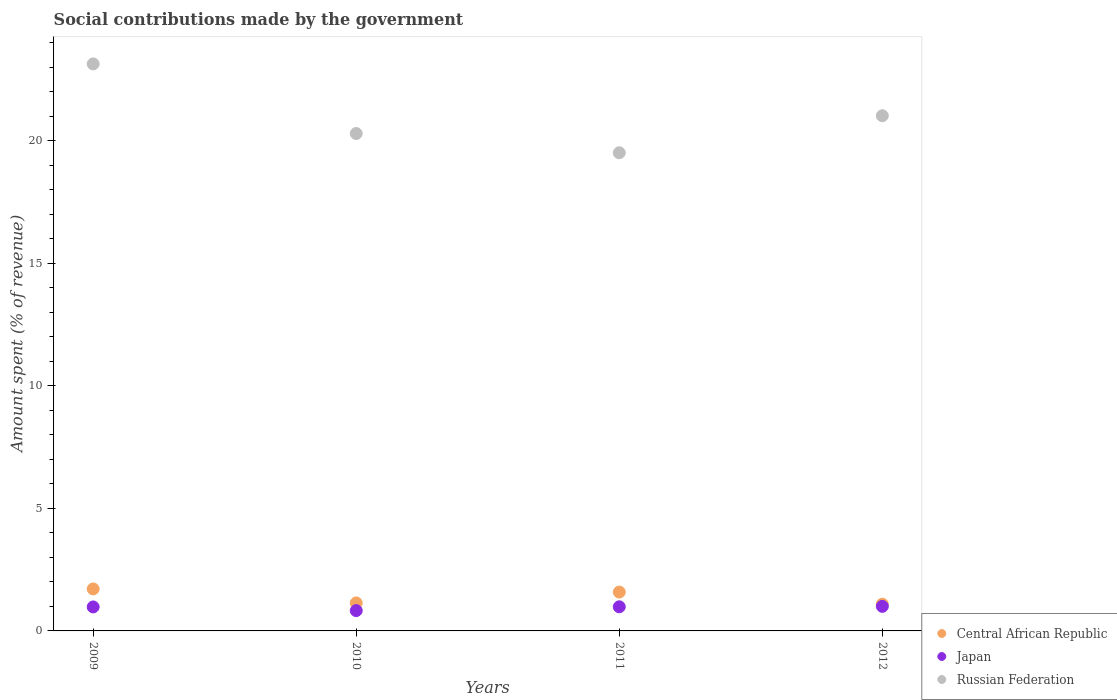What is the amount spent (in %) on social contributions in Russian Federation in 2011?
Make the answer very short. 19.5. Across all years, what is the maximum amount spent (in %) on social contributions in Central African Republic?
Make the answer very short. 1.71. Across all years, what is the minimum amount spent (in %) on social contributions in Russian Federation?
Offer a terse response. 19.5. What is the total amount spent (in %) on social contributions in Central African Republic in the graph?
Your response must be concise. 5.53. What is the difference between the amount spent (in %) on social contributions in Russian Federation in 2010 and that in 2011?
Provide a succinct answer. 0.78. What is the difference between the amount spent (in %) on social contributions in Central African Republic in 2011 and the amount spent (in %) on social contributions in Japan in 2010?
Your answer should be very brief. 0.76. What is the average amount spent (in %) on social contributions in Russian Federation per year?
Your response must be concise. 20.98. In the year 2010, what is the difference between the amount spent (in %) on social contributions in Russian Federation and amount spent (in %) on social contributions in Japan?
Offer a very short reply. 19.46. In how many years, is the amount spent (in %) on social contributions in Japan greater than 11 %?
Keep it short and to the point. 0. What is the ratio of the amount spent (in %) on social contributions in Japan in 2009 to that in 2010?
Give a very brief answer. 1.18. Is the difference between the amount spent (in %) on social contributions in Russian Federation in 2010 and 2012 greater than the difference between the amount spent (in %) on social contributions in Japan in 2010 and 2012?
Provide a succinct answer. No. What is the difference between the highest and the second highest amount spent (in %) on social contributions in Japan?
Your answer should be very brief. 0.02. What is the difference between the highest and the lowest amount spent (in %) on social contributions in Russian Federation?
Your response must be concise. 3.62. Is the sum of the amount spent (in %) on social contributions in Central African Republic in 2009 and 2010 greater than the maximum amount spent (in %) on social contributions in Japan across all years?
Make the answer very short. Yes. How many dotlines are there?
Make the answer very short. 3. Are the values on the major ticks of Y-axis written in scientific E-notation?
Offer a terse response. No. Does the graph contain grids?
Offer a terse response. No. What is the title of the graph?
Make the answer very short. Social contributions made by the government. Does "Kosovo" appear as one of the legend labels in the graph?
Provide a short and direct response. No. What is the label or title of the Y-axis?
Give a very brief answer. Amount spent (% of revenue). What is the Amount spent (% of revenue) in Central African Republic in 2009?
Keep it short and to the point. 1.71. What is the Amount spent (% of revenue) in Japan in 2009?
Ensure brevity in your answer.  0.98. What is the Amount spent (% of revenue) of Russian Federation in 2009?
Offer a very short reply. 23.13. What is the Amount spent (% of revenue) in Central African Republic in 2010?
Ensure brevity in your answer.  1.14. What is the Amount spent (% of revenue) in Japan in 2010?
Offer a very short reply. 0.83. What is the Amount spent (% of revenue) in Russian Federation in 2010?
Provide a short and direct response. 20.29. What is the Amount spent (% of revenue) of Central African Republic in 2011?
Give a very brief answer. 1.58. What is the Amount spent (% of revenue) of Japan in 2011?
Provide a short and direct response. 0.98. What is the Amount spent (% of revenue) of Russian Federation in 2011?
Your answer should be very brief. 19.5. What is the Amount spent (% of revenue) of Central African Republic in 2012?
Offer a very short reply. 1.09. What is the Amount spent (% of revenue) in Japan in 2012?
Your answer should be very brief. 1. What is the Amount spent (% of revenue) in Russian Federation in 2012?
Ensure brevity in your answer.  21.01. Across all years, what is the maximum Amount spent (% of revenue) in Central African Republic?
Make the answer very short. 1.71. Across all years, what is the maximum Amount spent (% of revenue) of Japan?
Provide a succinct answer. 1. Across all years, what is the maximum Amount spent (% of revenue) of Russian Federation?
Keep it short and to the point. 23.13. Across all years, what is the minimum Amount spent (% of revenue) in Central African Republic?
Offer a very short reply. 1.09. Across all years, what is the minimum Amount spent (% of revenue) of Japan?
Your answer should be compact. 0.83. Across all years, what is the minimum Amount spent (% of revenue) in Russian Federation?
Make the answer very short. 19.5. What is the total Amount spent (% of revenue) in Central African Republic in the graph?
Your answer should be very brief. 5.53. What is the total Amount spent (% of revenue) of Japan in the graph?
Make the answer very short. 3.79. What is the total Amount spent (% of revenue) in Russian Federation in the graph?
Provide a short and direct response. 83.94. What is the difference between the Amount spent (% of revenue) in Central African Republic in 2009 and that in 2010?
Provide a succinct answer. 0.57. What is the difference between the Amount spent (% of revenue) of Japan in 2009 and that in 2010?
Provide a short and direct response. 0.15. What is the difference between the Amount spent (% of revenue) in Russian Federation in 2009 and that in 2010?
Provide a short and direct response. 2.84. What is the difference between the Amount spent (% of revenue) of Central African Republic in 2009 and that in 2011?
Provide a succinct answer. 0.13. What is the difference between the Amount spent (% of revenue) in Japan in 2009 and that in 2011?
Provide a succinct answer. -0.01. What is the difference between the Amount spent (% of revenue) of Russian Federation in 2009 and that in 2011?
Offer a terse response. 3.62. What is the difference between the Amount spent (% of revenue) in Central African Republic in 2009 and that in 2012?
Offer a terse response. 0.62. What is the difference between the Amount spent (% of revenue) of Japan in 2009 and that in 2012?
Ensure brevity in your answer.  -0.02. What is the difference between the Amount spent (% of revenue) of Russian Federation in 2009 and that in 2012?
Offer a very short reply. 2.11. What is the difference between the Amount spent (% of revenue) in Central African Republic in 2010 and that in 2011?
Your answer should be compact. -0.44. What is the difference between the Amount spent (% of revenue) in Japan in 2010 and that in 2011?
Keep it short and to the point. -0.16. What is the difference between the Amount spent (% of revenue) in Russian Federation in 2010 and that in 2011?
Give a very brief answer. 0.78. What is the difference between the Amount spent (% of revenue) in Central African Republic in 2010 and that in 2012?
Offer a very short reply. 0.05. What is the difference between the Amount spent (% of revenue) in Japan in 2010 and that in 2012?
Give a very brief answer. -0.17. What is the difference between the Amount spent (% of revenue) in Russian Federation in 2010 and that in 2012?
Your response must be concise. -0.73. What is the difference between the Amount spent (% of revenue) of Central African Republic in 2011 and that in 2012?
Provide a short and direct response. 0.49. What is the difference between the Amount spent (% of revenue) of Japan in 2011 and that in 2012?
Offer a terse response. -0.02. What is the difference between the Amount spent (% of revenue) of Russian Federation in 2011 and that in 2012?
Keep it short and to the point. -1.51. What is the difference between the Amount spent (% of revenue) of Central African Republic in 2009 and the Amount spent (% of revenue) of Japan in 2010?
Your response must be concise. 0.88. What is the difference between the Amount spent (% of revenue) in Central African Republic in 2009 and the Amount spent (% of revenue) in Russian Federation in 2010?
Ensure brevity in your answer.  -18.58. What is the difference between the Amount spent (% of revenue) of Japan in 2009 and the Amount spent (% of revenue) of Russian Federation in 2010?
Provide a short and direct response. -19.31. What is the difference between the Amount spent (% of revenue) of Central African Republic in 2009 and the Amount spent (% of revenue) of Japan in 2011?
Keep it short and to the point. 0.73. What is the difference between the Amount spent (% of revenue) in Central African Republic in 2009 and the Amount spent (% of revenue) in Russian Federation in 2011?
Offer a terse response. -17.79. What is the difference between the Amount spent (% of revenue) in Japan in 2009 and the Amount spent (% of revenue) in Russian Federation in 2011?
Provide a succinct answer. -18.53. What is the difference between the Amount spent (% of revenue) in Central African Republic in 2009 and the Amount spent (% of revenue) in Japan in 2012?
Ensure brevity in your answer.  0.71. What is the difference between the Amount spent (% of revenue) in Central African Republic in 2009 and the Amount spent (% of revenue) in Russian Federation in 2012?
Your answer should be compact. -19.3. What is the difference between the Amount spent (% of revenue) of Japan in 2009 and the Amount spent (% of revenue) of Russian Federation in 2012?
Your answer should be compact. -20.04. What is the difference between the Amount spent (% of revenue) of Central African Republic in 2010 and the Amount spent (% of revenue) of Japan in 2011?
Give a very brief answer. 0.16. What is the difference between the Amount spent (% of revenue) of Central African Republic in 2010 and the Amount spent (% of revenue) of Russian Federation in 2011?
Your response must be concise. -18.36. What is the difference between the Amount spent (% of revenue) of Japan in 2010 and the Amount spent (% of revenue) of Russian Federation in 2011?
Offer a very short reply. -18.68. What is the difference between the Amount spent (% of revenue) of Central African Republic in 2010 and the Amount spent (% of revenue) of Japan in 2012?
Ensure brevity in your answer.  0.14. What is the difference between the Amount spent (% of revenue) in Central African Republic in 2010 and the Amount spent (% of revenue) in Russian Federation in 2012?
Make the answer very short. -19.87. What is the difference between the Amount spent (% of revenue) of Japan in 2010 and the Amount spent (% of revenue) of Russian Federation in 2012?
Offer a very short reply. -20.19. What is the difference between the Amount spent (% of revenue) of Central African Republic in 2011 and the Amount spent (% of revenue) of Japan in 2012?
Offer a terse response. 0.58. What is the difference between the Amount spent (% of revenue) in Central African Republic in 2011 and the Amount spent (% of revenue) in Russian Federation in 2012?
Your answer should be compact. -19.43. What is the difference between the Amount spent (% of revenue) of Japan in 2011 and the Amount spent (% of revenue) of Russian Federation in 2012?
Provide a succinct answer. -20.03. What is the average Amount spent (% of revenue) in Central African Republic per year?
Ensure brevity in your answer.  1.38. What is the average Amount spent (% of revenue) of Japan per year?
Keep it short and to the point. 0.95. What is the average Amount spent (% of revenue) in Russian Federation per year?
Keep it short and to the point. 20.98. In the year 2009, what is the difference between the Amount spent (% of revenue) of Central African Republic and Amount spent (% of revenue) of Japan?
Keep it short and to the point. 0.73. In the year 2009, what is the difference between the Amount spent (% of revenue) in Central African Republic and Amount spent (% of revenue) in Russian Federation?
Make the answer very short. -21.41. In the year 2009, what is the difference between the Amount spent (% of revenue) of Japan and Amount spent (% of revenue) of Russian Federation?
Offer a very short reply. -22.15. In the year 2010, what is the difference between the Amount spent (% of revenue) of Central African Republic and Amount spent (% of revenue) of Japan?
Your answer should be very brief. 0.31. In the year 2010, what is the difference between the Amount spent (% of revenue) of Central African Republic and Amount spent (% of revenue) of Russian Federation?
Offer a very short reply. -19.15. In the year 2010, what is the difference between the Amount spent (% of revenue) of Japan and Amount spent (% of revenue) of Russian Federation?
Make the answer very short. -19.46. In the year 2011, what is the difference between the Amount spent (% of revenue) of Central African Republic and Amount spent (% of revenue) of Japan?
Your answer should be very brief. 0.6. In the year 2011, what is the difference between the Amount spent (% of revenue) of Central African Republic and Amount spent (% of revenue) of Russian Federation?
Your answer should be very brief. -17.92. In the year 2011, what is the difference between the Amount spent (% of revenue) in Japan and Amount spent (% of revenue) in Russian Federation?
Keep it short and to the point. -18.52. In the year 2012, what is the difference between the Amount spent (% of revenue) in Central African Republic and Amount spent (% of revenue) in Japan?
Your response must be concise. 0.09. In the year 2012, what is the difference between the Amount spent (% of revenue) of Central African Republic and Amount spent (% of revenue) of Russian Federation?
Your answer should be compact. -19.92. In the year 2012, what is the difference between the Amount spent (% of revenue) of Japan and Amount spent (% of revenue) of Russian Federation?
Make the answer very short. -20.01. What is the ratio of the Amount spent (% of revenue) in Central African Republic in 2009 to that in 2010?
Your answer should be very brief. 1.5. What is the ratio of the Amount spent (% of revenue) of Japan in 2009 to that in 2010?
Make the answer very short. 1.18. What is the ratio of the Amount spent (% of revenue) in Russian Federation in 2009 to that in 2010?
Provide a short and direct response. 1.14. What is the ratio of the Amount spent (% of revenue) in Central African Republic in 2009 to that in 2011?
Your answer should be compact. 1.08. What is the ratio of the Amount spent (% of revenue) of Japan in 2009 to that in 2011?
Offer a terse response. 0.99. What is the ratio of the Amount spent (% of revenue) of Russian Federation in 2009 to that in 2011?
Offer a terse response. 1.19. What is the ratio of the Amount spent (% of revenue) in Central African Republic in 2009 to that in 2012?
Ensure brevity in your answer.  1.57. What is the ratio of the Amount spent (% of revenue) of Japan in 2009 to that in 2012?
Provide a succinct answer. 0.98. What is the ratio of the Amount spent (% of revenue) of Russian Federation in 2009 to that in 2012?
Provide a succinct answer. 1.1. What is the ratio of the Amount spent (% of revenue) in Central African Republic in 2010 to that in 2011?
Provide a short and direct response. 0.72. What is the ratio of the Amount spent (% of revenue) in Japan in 2010 to that in 2011?
Your answer should be compact. 0.84. What is the ratio of the Amount spent (% of revenue) of Russian Federation in 2010 to that in 2011?
Your answer should be compact. 1.04. What is the ratio of the Amount spent (% of revenue) of Central African Republic in 2010 to that in 2012?
Offer a terse response. 1.05. What is the ratio of the Amount spent (% of revenue) in Japan in 2010 to that in 2012?
Your response must be concise. 0.83. What is the ratio of the Amount spent (% of revenue) of Russian Federation in 2010 to that in 2012?
Provide a short and direct response. 0.97. What is the ratio of the Amount spent (% of revenue) in Central African Republic in 2011 to that in 2012?
Your answer should be very brief. 1.45. What is the ratio of the Amount spent (% of revenue) of Japan in 2011 to that in 2012?
Your response must be concise. 0.98. What is the ratio of the Amount spent (% of revenue) of Russian Federation in 2011 to that in 2012?
Offer a terse response. 0.93. What is the difference between the highest and the second highest Amount spent (% of revenue) in Central African Republic?
Make the answer very short. 0.13. What is the difference between the highest and the second highest Amount spent (% of revenue) in Japan?
Your answer should be compact. 0.02. What is the difference between the highest and the second highest Amount spent (% of revenue) in Russian Federation?
Your response must be concise. 2.11. What is the difference between the highest and the lowest Amount spent (% of revenue) in Central African Republic?
Offer a very short reply. 0.62. What is the difference between the highest and the lowest Amount spent (% of revenue) in Japan?
Ensure brevity in your answer.  0.17. What is the difference between the highest and the lowest Amount spent (% of revenue) of Russian Federation?
Ensure brevity in your answer.  3.62. 